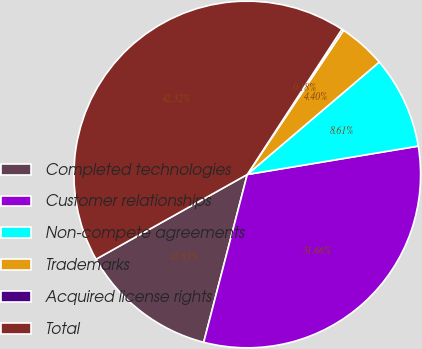Convert chart to OTSL. <chart><loc_0><loc_0><loc_500><loc_500><pie_chart><fcel>Completed technologies<fcel>Customer relationships<fcel>Non-compete agreements<fcel>Trademarks<fcel>Acquired license rights<fcel>Total<nl><fcel>12.83%<fcel>31.66%<fcel>8.61%<fcel>4.4%<fcel>0.18%<fcel>42.32%<nl></chart> 